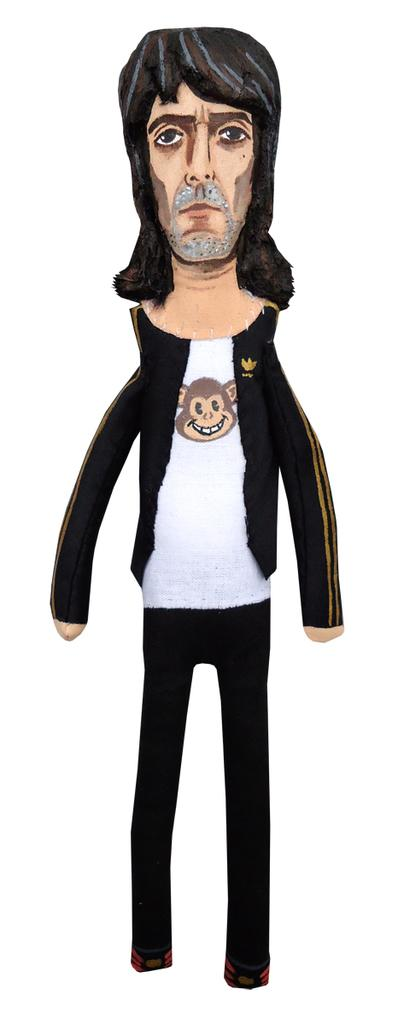What type of image is present in the picture? There is an animated image of a person in the image. What type of van can be seen in the image? There is no van present in the image; it only features an animated image of a person. What mark is visible on the person's clothing in the image? There is no mark visible on the person's clothing in the image, as it is an animated image and not a photograph or realistic depiction. 